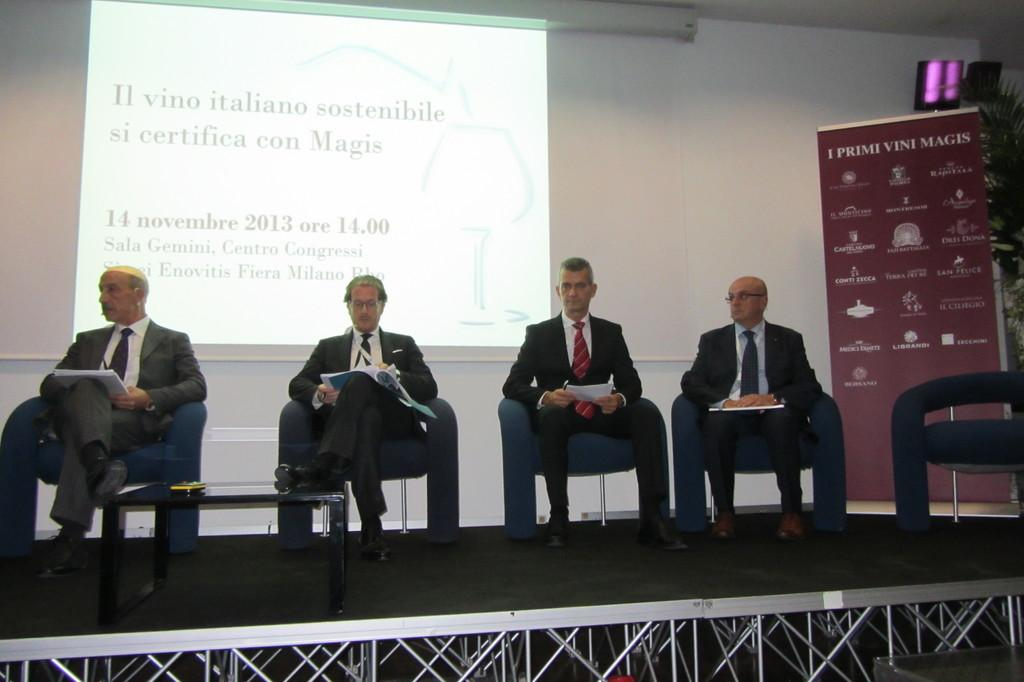How many people are in the image? There are four persons in the image. What are the persons doing in the image? The persons are sitting on chairs. What is the main object in the center of the image? There is a table in the image. What can be seen in the background of the image? There is a screen and a wall in the background of the image. What additional item is present in the image? There is a banner in the image. What are the names of the dolls sitting on the chairs in the image? There are no dolls present in the image; the persons sitting on the chairs are human. What type of coal is being used to fuel the screen in the background? There is no coal present in the image, and the screen is not fueled by coal. 